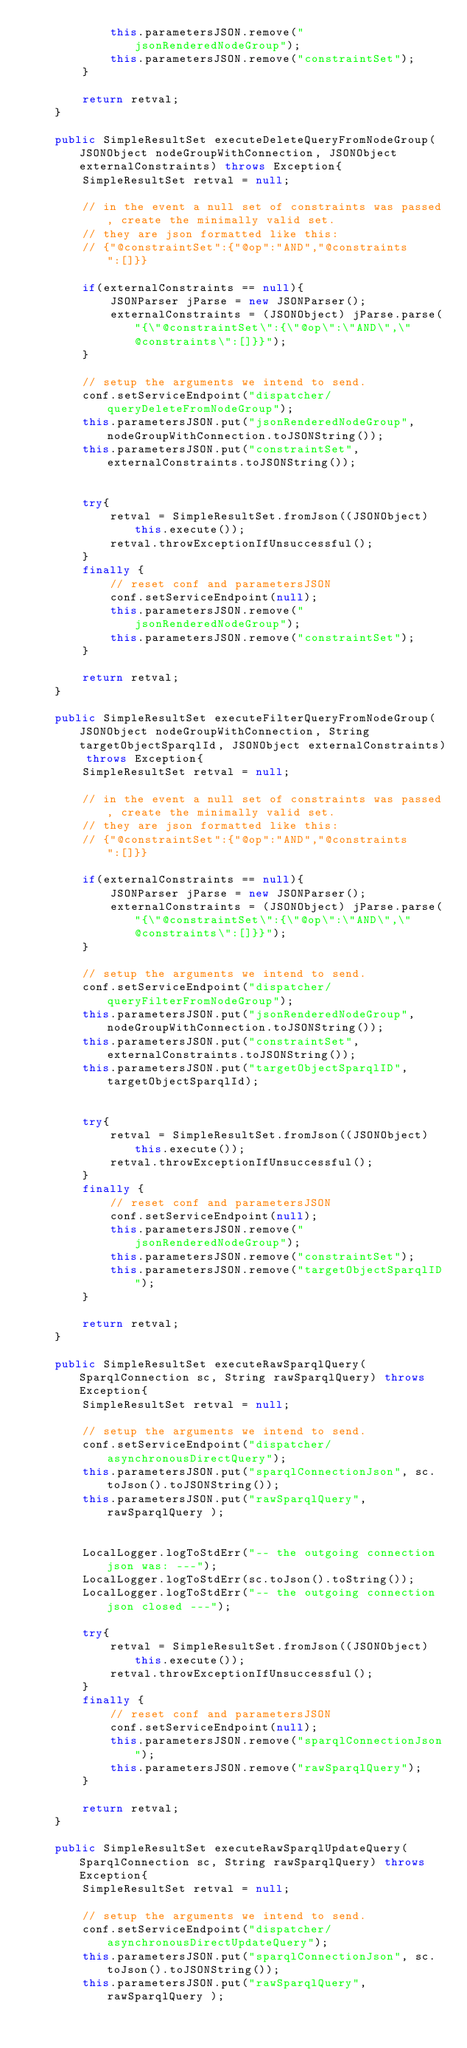Convert code to text. <code><loc_0><loc_0><loc_500><loc_500><_Java_>			this.parametersJSON.remove("jsonRenderedNodeGroup");
			this.parametersJSON.remove("constraintSet");
		}
		
		return retval;
	}
	
	public SimpleResultSet executeDeleteQueryFromNodeGroup(JSONObject nodeGroupWithConnection, JSONObject externalConstraints) throws Exception{
		SimpleResultSet retval = null;
		
		// in the event a null set of constraints was passed, create the minimally valid set.
		// they are json formatted like this:
		// {"@constraintSet":{"@op":"AND","@constraints":[]}}
		
		if(externalConstraints == null){
			JSONParser jParse = new JSONParser();
			externalConstraints = (JSONObject) jParse.parse("{\"@constraintSet\":{\"@op\":\"AND\",\"@constraints\":[]}}");	
		}
		
		// setup the arguments we intend to send.
		conf.setServiceEndpoint("dispatcher/queryDeleteFromNodeGroup");
		this.parametersJSON.put("jsonRenderedNodeGroup", nodeGroupWithConnection.toJSONString());
		this.parametersJSON.put("constraintSet", externalConstraints.toJSONString());
		
		
		try{
			retval = SimpleResultSet.fromJson((JSONObject) this.execute());
			retval.throwExceptionIfUnsuccessful();
		} 
		finally {
			// reset conf and parametersJSON
			conf.setServiceEndpoint(null);
			this.parametersJSON.remove("jsonRenderedNodeGroup");
			this.parametersJSON.remove("constraintSet");
		}
		
		return retval;
	}
	
	public SimpleResultSet executeFilterQueryFromNodeGroup(JSONObject nodeGroupWithConnection, String targetObjectSparqlId, JSONObject externalConstraints) throws Exception{
		SimpleResultSet retval = null;
		
		// in the event a null set of constraints was passed, create the minimally valid set.
		// they are json formatted like this:
		// {"@constraintSet":{"@op":"AND","@constraints":[]}}
		
		if(externalConstraints == null){
			JSONParser jParse = new JSONParser();
			externalConstraints = (JSONObject) jParse.parse("{\"@constraintSet\":{\"@op\":\"AND\",\"@constraints\":[]}}");	
		}
		
		// setup the arguments we intend to send.
		conf.setServiceEndpoint("dispatcher/queryFilterFromNodeGroup");
		this.parametersJSON.put("jsonRenderedNodeGroup", nodeGroupWithConnection.toJSONString());
		this.parametersJSON.put("constraintSet", externalConstraints.toJSONString());
		this.parametersJSON.put("targetObjectSparqlID", targetObjectSparqlId);
		
		
		try{
			retval = SimpleResultSet.fromJson((JSONObject) this.execute());
			retval.throwExceptionIfUnsuccessful();
		} 
		finally {
			// reset conf and parametersJSON
			conf.setServiceEndpoint(null);
			this.parametersJSON.remove("jsonRenderedNodeGroup");
			this.parametersJSON.remove("constraintSet");
			this.parametersJSON.remove("targetObjectSparqlID");
		}
		
		return retval;
	}
	
	public SimpleResultSet executeRawSparqlQuery(SparqlConnection sc, String rawSparqlQuery) throws Exception{
		SimpleResultSet retval = null;
		
		// setup the arguments we intend to send.
		conf.setServiceEndpoint("dispatcher/asynchronousDirectQuery");
		this.parametersJSON.put("sparqlConnectionJson", sc.toJson().toJSONString());
		this.parametersJSON.put("rawSparqlQuery", rawSparqlQuery );
	
		
		LocalLogger.logToStdErr("-- the outgoing connection json was: ---");
		LocalLogger.logToStdErr(sc.toJson().toString());
		LocalLogger.logToStdErr("-- the outgoing connection json closed ---");
		
		try{
			retval = SimpleResultSet.fromJson((JSONObject) this.execute());
			retval.throwExceptionIfUnsuccessful();
		} 
		finally {
			// reset conf and parametersJSON
			conf.setServiceEndpoint(null);
			this.parametersJSON.remove("sparqlConnectionJson");
			this.parametersJSON.remove("rawSparqlQuery");
		}
		
		return retval;
	}
	
	public SimpleResultSet executeRawSparqlUpdateQuery(SparqlConnection sc, String rawSparqlQuery) throws Exception{
		SimpleResultSet retval = null;
		
		// setup the arguments we intend to send.
		conf.setServiceEndpoint("dispatcher/asynchronousDirectUpdateQuery");
		this.parametersJSON.put("sparqlConnectionJson", sc.toJson().toJSONString());
		this.parametersJSON.put("rawSparqlQuery", rawSparqlQuery );
	
		</code> 